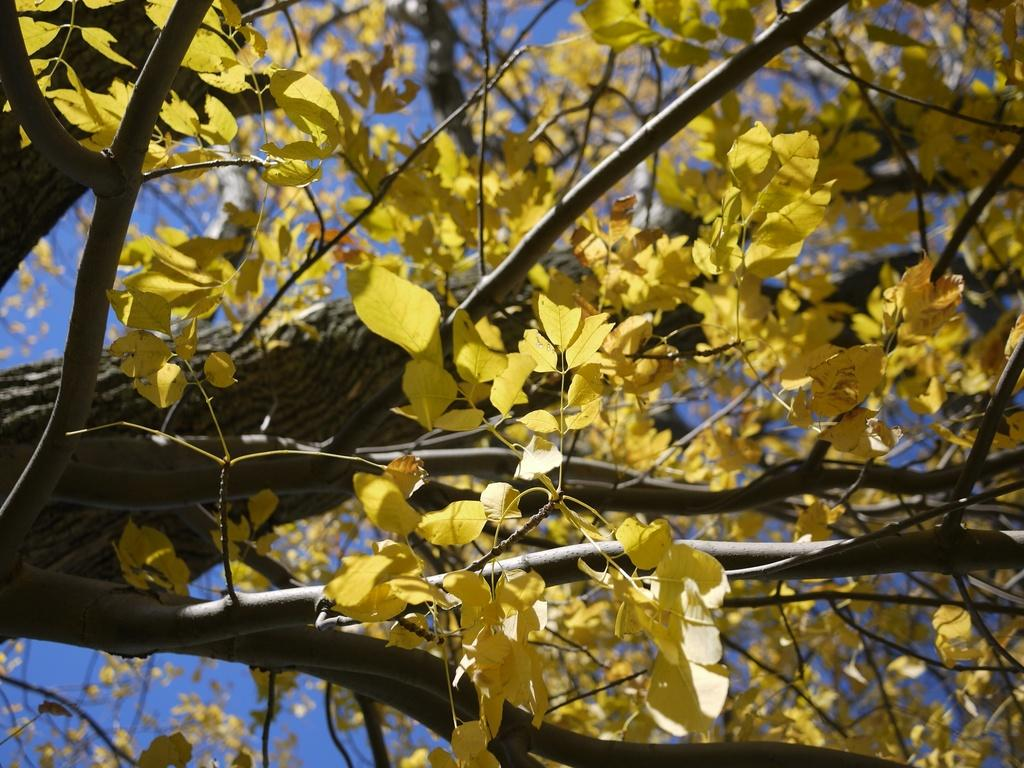What color are the leaves on the tree in the image? The leaves on the tree in the image are yellow. What color is the sky in the image? The sky is blue in color. Can you see a gun in the image? No, there is no gun present in the image. Is anyone asking for help in the image? There is no indication of anyone asking for help in the image. 